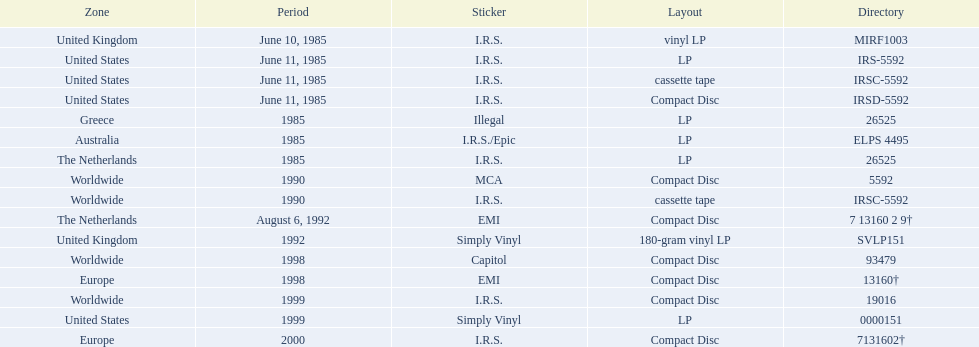In how many countries was the album released before 1990? 5. 